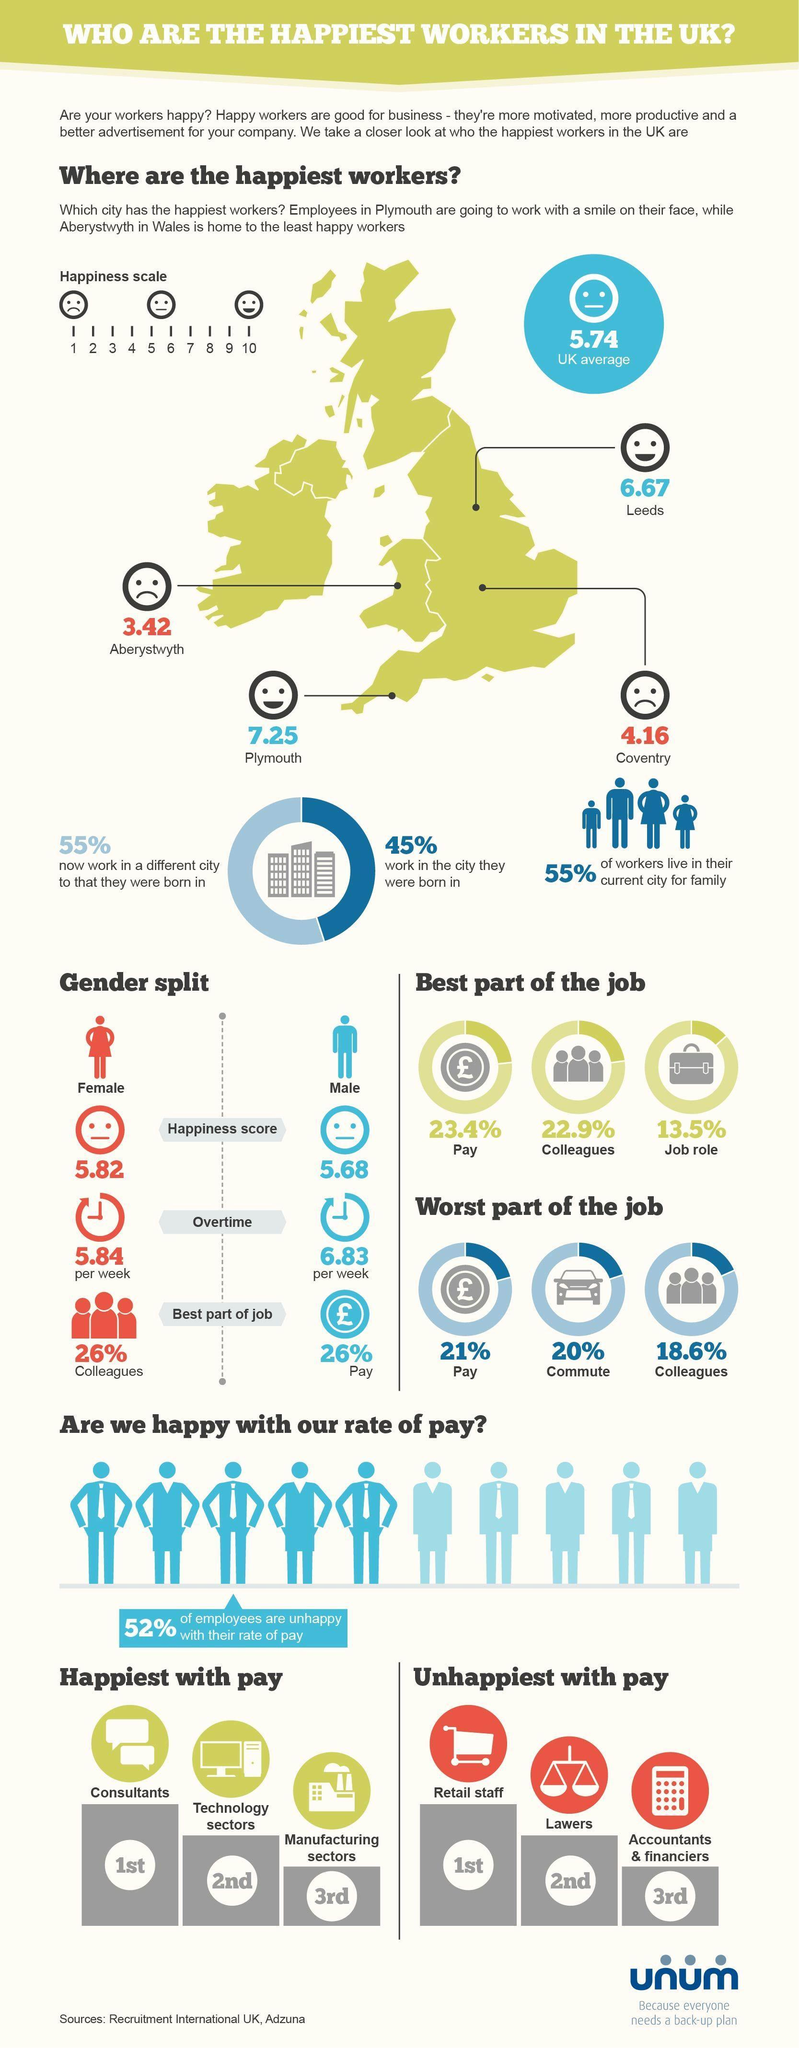What percent of employees are happy with their rate of pay?
Answer the question with a short phrase. 48% Which gender has better happiness score? Female After Plymouth, which city has happiest workers? Leeds Who are the happiest with pay? Consultants Who does more overtime- male or female? Male Which parameter is both best and worst part of the job for a majority of people? Pay Which two cities are below the UK average? Aberystwyth, Coventry 